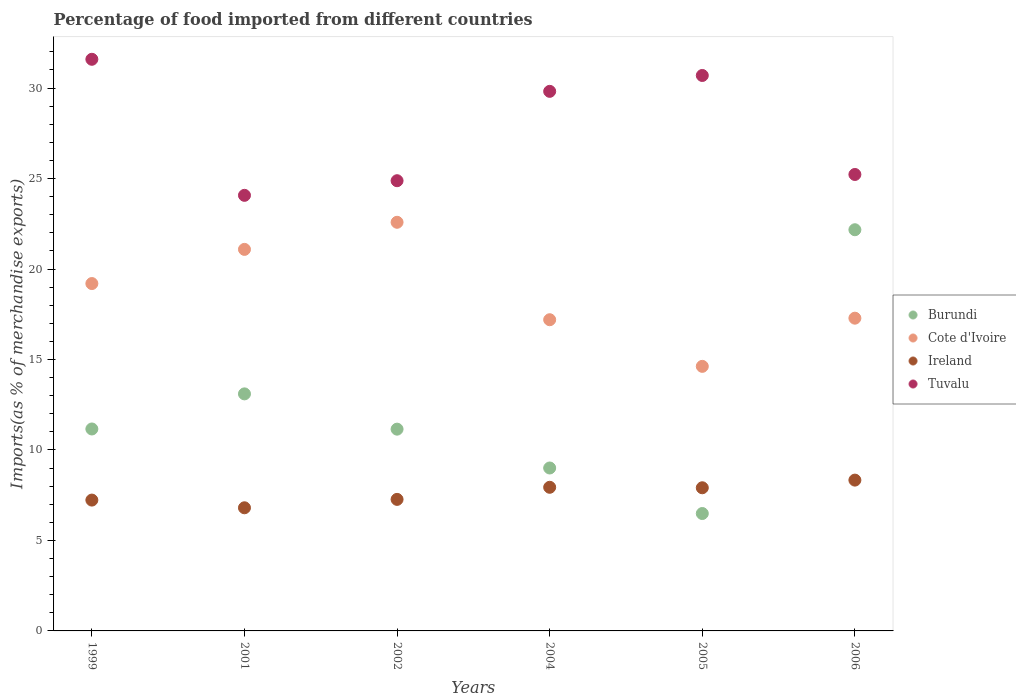What is the percentage of imports to different countries in Ireland in 1999?
Offer a terse response. 7.23. Across all years, what is the maximum percentage of imports to different countries in Tuvalu?
Provide a succinct answer. 31.59. Across all years, what is the minimum percentage of imports to different countries in Burundi?
Your answer should be very brief. 6.49. In which year was the percentage of imports to different countries in Cote d'Ivoire maximum?
Offer a very short reply. 2002. In which year was the percentage of imports to different countries in Cote d'Ivoire minimum?
Keep it short and to the point. 2005. What is the total percentage of imports to different countries in Ireland in the graph?
Your answer should be compact. 45.49. What is the difference between the percentage of imports to different countries in Cote d'Ivoire in 2001 and that in 2006?
Make the answer very short. 3.8. What is the difference between the percentage of imports to different countries in Cote d'Ivoire in 1999 and the percentage of imports to different countries in Ireland in 2005?
Provide a succinct answer. 11.29. What is the average percentage of imports to different countries in Cote d'Ivoire per year?
Keep it short and to the point. 18.66. In the year 2005, what is the difference between the percentage of imports to different countries in Tuvalu and percentage of imports to different countries in Burundi?
Give a very brief answer. 24.21. What is the ratio of the percentage of imports to different countries in Tuvalu in 2004 to that in 2006?
Provide a short and direct response. 1.18. Is the percentage of imports to different countries in Ireland in 2005 less than that in 2006?
Make the answer very short. Yes. Is the difference between the percentage of imports to different countries in Tuvalu in 2004 and 2005 greater than the difference between the percentage of imports to different countries in Burundi in 2004 and 2005?
Your response must be concise. No. What is the difference between the highest and the second highest percentage of imports to different countries in Cote d'Ivoire?
Offer a terse response. 1.5. What is the difference between the highest and the lowest percentage of imports to different countries in Burundi?
Provide a succinct answer. 15.68. Is it the case that in every year, the sum of the percentage of imports to different countries in Burundi and percentage of imports to different countries in Cote d'Ivoire  is greater than the sum of percentage of imports to different countries in Ireland and percentage of imports to different countries in Tuvalu?
Provide a succinct answer. Yes. Is the percentage of imports to different countries in Cote d'Ivoire strictly less than the percentage of imports to different countries in Tuvalu over the years?
Provide a short and direct response. Yes. What is the difference between two consecutive major ticks on the Y-axis?
Your answer should be very brief. 5. How are the legend labels stacked?
Provide a succinct answer. Vertical. What is the title of the graph?
Your response must be concise. Percentage of food imported from different countries. Does "Iceland" appear as one of the legend labels in the graph?
Offer a terse response. No. What is the label or title of the X-axis?
Give a very brief answer. Years. What is the label or title of the Y-axis?
Ensure brevity in your answer.  Imports(as % of merchandise exports). What is the Imports(as % of merchandise exports) in Burundi in 1999?
Provide a short and direct response. 11.16. What is the Imports(as % of merchandise exports) in Cote d'Ivoire in 1999?
Provide a short and direct response. 19.2. What is the Imports(as % of merchandise exports) in Ireland in 1999?
Offer a terse response. 7.23. What is the Imports(as % of merchandise exports) of Tuvalu in 1999?
Your response must be concise. 31.59. What is the Imports(as % of merchandise exports) of Burundi in 2001?
Keep it short and to the point. 13.1. What is the Imports(as % of merchandise exports) in Cote d'Ivoire in 2001?
Ensure brevity in your answer.  21.09. What is the Imports(as % of merchandise exports) in Ireland in 2001?
Your answer should be compact. 6.8. What is the Imports(as % of merchandise exports) in Tuvalu in 2001?
Make the answer very short. 24.07. What is the Imports(as % of merchandise exports) of Burundi in 2002?
Offer a very short reply. 11.15. What is the Imports(as % of merchandise exports) in Cote d'Ivoire in 2002?
Your answer should be very brief. 22.58. What is the Imports(as % of merchandise exports) of Ireland in 2002?
Your answer should be compact. 7.27. What is the Imports(as % of merchandise exports) of Tuvalu in 2002?
Provide a succinct answer. 24.88. What is the Imports(as % of merchandise exports) of Burundi in 2004?
Provide a short and direct response. 9. What is the Imports(as % of merchandise exports) in Cote d'Ivoire in 2004?
Make the answer very short. 17.2. What is the Imports(as % of merchandise exports) in Ireland in 2004?
Offer a very short reply. 7.94. What is the Imports(as % of merchandise exports) in Tuvalu in 2004?
Keep it short and to the point. 29.82. What is the Imports(as % of merchandise exports) of Burundi in 2005?
Ensure brevity in your answer.  6.49. What is the Imports(as % of merchandise exports) in Cote d'Ivoire in 2005?
Provide a short and direct response. 14.62. What is the Imports(as % of merchandise exports) of Ireland in 2005?
Offer a very short reply. 7.91. What is the Imports(as % of merchandise exports) in Tuvalu in 2005?
Provide a short and direct response. 30.7. What is the Imports(as % of merchandise exports) of Burundi in 2006?
Ensure brevity in your answer.  22.17. What is the Imports(as % of merchandise exports) of Cote d'Ivoire in 2006?
Your response must be concise. 17.28. What is the Imports(as % of merchandise exports) of Ireland in 2006?
Provide a succinct answer. 8.33. What is the Imports(as % of merchandise exports) in Tuvalu in 2006?
Offer a very short reply. 25.22. Across all years, what is the maximum Imports(as % of merchandise exports) of Burundi?
Offer a very short reply. 22.17. Across all years, what is the maximum Imports(as % of merchandise exports) of Cote d'Ivoire?
Give a very brief answer. 22.58. Across all years, what is the maximum Imports(as % of merchandise exports) of Ireland?
Provide a short and direct response. 8.33. Across all years, what is the maximum Imports(as % of merchandise exports) of Tuvalu?
Offer a terse response. 31.59. Across all years, what is the minimum Imports(as % of merchandise exports) in Burundi?
Make the answer very short. 6.49. Across all years, what is the minimum Imports(as % of merchandise exports) in Cote d'Ivoire?
Make the answer very short. 14.62. Across all years, what is the minimum Imports(as % of merchandise exports) of Ireland?
Your answer should be very brief. 6.8. Across all years, what is the minimum Imports(as % of merchandise exports) in Tuvalu?
Provide a succinct answer. 24.07. What is the total Imports(as % of merchandise exports) in Burundi in the graph?
Give a very brief answer. 73.07. What is the total Imports(as % of merchandise exports) in Cote d'Ivoire in the graph?
Provide a short and direct response. 111.97. What is the total Imports(as % of merchandise exports) of Ireland in the graph?
Provide a succinct answer. 45.49. What is the total Imports(as % of merchandise exports) of Tuvalu in the graph?
Keep it short and to the point. 166.28. What is the difference between the Imports(as % of merchandise exports) in Burundi in 1999 and that in 2001?
Your response must be concise. -1.94. What is the difference between the Imports(as % of merchandise exports) of Cote d'Ivoire in 1999 and that in 2001?
Provide a short and direct response. -1.89. What is the difference between the Imports(as % of merchandise exports) of Ireland in 1999 and that in 2001?
Provide a short and direct response. 0.43. What is the difference between the Imports(as % of merchandise exports) of Tuvalu in 1999 and that in 2001?
Your answer should be compact. 7.52. What is the difference between the Imports(as % of merchandise exports) of Burundi in 1999 and that in 2002?
Give a very brief answer. 0.01. What is the difference between the Imports(as % of merchandise exports) of Cote d'Ivoire in 1999 and that in 2002?
Your answer should be compact. -3.39. What is the difference between the Imports(as % of merchandise exports) in Ireland in 1999 and that in 2002?
Your response must be concise. -0.04. What is the difference between the Imports(as % of merchandise exports) of Tuvalu in 1999 and that in 2002?
Your answer should be very brief. 6.71. What is the difference between the Imports(as % of merchandise exports) of Burundi in 1999 and that in 2004?
Ensure brevity in your answer.  2.16. What is the difference between the Imports(as % of merchandise exports) in Cote d'Ivoire in 1999 and that in 2004?
Provide a short and direct response. 2. What is the difference between the Imports(as % of merchandise exports) in Ireland in 1999 and that in 2004?
Ensure brevity in your answer.  -0.71. What is the difference between the Imports(as % of merchandise exports) in Tuvalu in 1999 and that in 2004?
Offer a very short reply. 1.77. What is the difference between the Imports(as % of merchandise exports) of Burundi in 1999 and that in 2005?
Keep it short and to the point. 4.67. What is the difference between the Imports(as % of merchandise exports) of Cote d'Ivoire in 1999 and that in 2005?
Your response must be concise. 4.58. What is the difference between the Imports(as % of merchandise exports) of Ireland in 1999 and that in 2005?
Your answer should be compact. -0.68. What is the difference between the Imports(as % of merchandise exports) of Tuvalu in 1999 and that in 2005?
Keep it short and to the point. 0.89. What is the difference between the Imports(as % of merchandise exports) in Burundi in 1999 and that in 2006?
Provide a short and direct response. -11.01. What is the difference between the Imports(as % of merchandise exports) in Cote d'Ivoire in 1999 and that in 2006?
Your response must be concise. 1.91. What is the difference between the Imports(as % of merchandise exports) of Ireland in 1999 and that in 2006?
Ensure brevity in your answer.  -1.1. What is the difference between the Imports(as % of merchandise exports) of Tuvalu in 1999 and that in 2006?
Ensure brevity in your answer.  6.37. What is the difference between the Imports(as % of merchandise exports) of Burundi in 2001 and that in 2002?
Offer a terse response. 1.95. What is the difference between the Imports(as % of merchandise exports) in Cote d'Ivoire in 2001 and that in 2002?
Your answer should be compact. -1.5. What is the difference between the Imports(as % of merchandise exports) in Ireland in 2001 and that in 2002?
Keep it short and to the point. -0.46. What is the difference between the Imports(as % of merchandise exports) of Tuvalu in 2001 and that in 2002?
Your response must be concise. -0.81. What is the difference between the Imports(as % of merchandise exports) in Burundi in 2001 and that in 2004?
Your answer should be very brief. 4.1. What is the difference between the Imports(as % of merchandise exports) of Cote d'Ivoire in 2001 and that in 2004?
Your response must be concise. 3.89. What is the difference between the Imports(as % of merchandise exports) in Ireland in 2001 and that in 2004?
Keep it short and to the point. -1.13. What is the difference between the Imports(as % of merchandise exports) of Tuvalu in 2001 and that in 2004?
Provide a short and direct response. -5.75. What is the difference between the Imports(as % of merchandise exports) of Burundi in 2001 and that in 2005?
Give a very brief answer. 6.61. What is the difference between the Imports(as % of merchandise exports) in Cote d'Ivoire in 2001 and that in 2005?
Offer a very short reply. 6.46. What is the difference between the Imports(as % of merchandise exports) of Ireland in 2001 and that in 2005?
Offer a very short reply. -1.11. What is the difference between the Imports(as % of merchandise exports) of Tuvalu in 2001 and that in 2005?
Give a very brief answer. -6.62. What is the difference between the Imports(as % of merchandise exports) of Burundi in 2001 and that in 2006?
Offer a terse response. -9.07. What is the difference between the Imports(as % of merchandise exports) in Cote d'Ivoire in 2001 and that in 2006?
Provide a short and direct response. 3.8. What is the difference between the Imports(as % of merchandise exports) of Ireland in 2001 and that in 2006?
Provide a short and direct response. -1.53. What is the difference between the Imports(as % of merchandise exports) of Tuvalu in 2001 and that in 2006?
Keep it short and to the point. -1.15. What is the difference between the Imports(as % of merchandise exports) in Burundi in 2002 and that in 2004?
Your answer should be very brief. 2.15. What is the difference between the Imports(as % of merchandise exports) of Cote d'Ivoire in 2002 and that in 2004?
Provide a short and direct response. 5.38. What is the difference between the Imports(as % of merchandise exports) in Ireland in 2002 and that in 2004?
Provide a short and direct response. -0.67. What is the difference between the Imports(as % of merchandise exports) of Tuvalu in 2002 and that in 2004?
Make the answer very short. -4.94. What is the difference between the Imports(as % of merchandise exports) in Burundi in 2002 and that in 2005?
Offer a terse response. 4.66. What is the difference between the Imports(as % of merchandise exports) of Cote d'Ivoire in 2002 and that in 2005?
Keep it short and to the point. 7.96. What is the difference between the Imports(as % of merchandise exports) of Ireland in 2002 and that in 2005?
Give a very brief answer. -0.64. What is the difference between the Imports(as % of merchandise exports) in Tuvalu in 2002 and that in 2005?
Provide a succinct answer. -5.82. What is the difference between the Imports(as % of merchandise exports) in Burundi in 2002 and that in 2006?
Offer a terse response. -11.02. What is the difference between the Imports(as % of merchandise exports) in Cote d'Ivoire in 2002 and that in 2006?
Make the answer very short. 5.3. What is the difference between the Imports(as % of merchandise exports) of Ireland in 2002 and that in 2006?
Provide a short and direct response. -1.07. What is the difference between the Imports(as % of merchandise exports) in Tuvalu in 2002 and that in 2006?
Provide a short and direct response. -0.34. What is the difference between the Imports(as % of merchandise exports) of Burundi in 2004 and that in 2005?
Ensure brevity in your answer.  2.52. What is the difference between the Imports(as % of merchandise exports) of Cote d'Ivoire in 2004 and that in 2005?
Provide a short and direct response. 2.58. What is the difference between the Imports(as % of merchandise exports) of Ireland in 2004 and that in 2005?
Give a very brief answer. 0.03. What is the difference between the Imports(as % of merchandise exports) in Tuvalu in 2004 and that in 2005?
Provide a short and direct response. -0.88. What is the difference between the Imports(as % of merchandise exports) of Burundi in 2004 and that in 2006?
Give a very brief answer. -13.17. What is the difference between the Imports(as % of merchandise exports) of Cote d'Ivoire in 2004 and that in 2006?
Keep it short and to the point. -0.09. What is the difference between the Imports(as % of merchandise exports) in Ireland in 2004 and that in 2006?
Offer a very short reply. -0.4. What is the difference between the Imports(as % of merchandise exports) in Tuvalu in 2004 and that in 2006?
Provide a succinct answer. 4.59. What is the difference between the Imports(as % of merchandise exports) in Burundi in 2005 and that in 2006?
Make the answer very short. -15.68. What is the difference between the Imports(as % of merchandise exports) in Cote d'Ivoire in 2005 and that in 2006?
Give a very brief answer. -2.66. What is the difference between the Imports(as % of merchandise exports) of Ireland in 2005 and that in 2006?
Provide a succinct answer. -0.42. What is the difference between the Imports(as % of merchandise exports) in Tuvalu in 2005 and that in 2006?
Provide a short and direct response. 5.47. What is the difference between the Imports(as % of merchandise exports) in Burundi in 1999 and the Imports(as % of merchandise exports) in Cote d'Ivoire in 2001?
Offer a terse response. -9.93. What is the difference between the Imports(as % of merchandise exports) of Burundi in 1999 and the Imports(as % of merchandise exports) of Ireland in 2001?
Your answer should be very brief. 4.36. What is the difference between the Imports(as % of merchandise exports) of Burundi in 1999 and the Imports(as % of merchandise exports) of Tuvalu in 2001?
Ensure brevity in your answer.  -12.91. What is the difference between the Imports(as % of merchandise exports) of Cote d'Ivoire in 1999 and the Imports(as % of merchandise exports) of Ireland in 2001?
Keep it short and to the point. 12.39. What is the difference between the Imports(as % of merchandise exports) in Cote d'Ivoire in 1999 and the Imports(as % of merchandise exports) in Tuvalu in 2001?
Ensure brevity in your answer.  -4.88. What is the difference between the Imports(as % of merchandise exports) of Ireland in 1999 and the Imports(as % of merchandise exports) of Tuvalu in 2001?
Ensure brevity in your answer.  -16.84. What is the difference between the Imports(as % of merchandise exports) of Burundi in 1999 and the Imports(as % of merchandise exports) of Cote d'Ivoire in 2002?
Keep it short and to the point. -11.42. What is the difference between the Imports(as % of merchandise exports) of Burundi in 1999 and the Imports(as % of merchandise exports) of Ireland in 2002?
Keep it short and to the point. 3.89. What is the difference between the Imports(as % of merchandise exports) in Burundi in 1999 and the Imports(as % of merchandise exports) in Tuvalu in 2002?
Offer a terse response. -13.72. What is the difference between the Imports(as % of merchandise exports) in Cote d'Ivoire in 1999 and the Imports(as % of merchandise exports) in Ireland in 2002?
Your response must be concise. 11.93. What is the difference between the Imports(as % of merchandise exports) in Cote d'Ivoire in 1999 and the Imports(as % of merchandise exports) in Tuvalu in 2002?
Offer a terse response. -5.68. What is the difference between the Imports(as % of merchandise exports) in Ireland in 1999 and the Imports(as % of merchandise exports) in Tuvalu in 2002?
Your answer should be compact. -17.65. What is the difference between the Imports(as % of merchandise exports) in Burundi in 1999 and the Imports(as % of merchandise exports) in Cote d'Ivoire in 2004?
Your answer should be very brief. -6.04. What is the difference between the Imports(as % of merchandise exports) of Burundi in 1999 and the Imports(as % of merchandise exports) of Ireland in 2004?
Ensure brevity in your answer.  3.22. What is the difference between the Imports(as % of merchandise exports) of Burundi in 1999 and the Imports(as % of merchandise exports) of Tuvalu in 2004?
Offer a very short reply. -18.66. What is the difference between the Imports(as % of merchandise exports) in Cote d'Ivoire in 1999 and the Imports(as % of merchandise exports) in Ireland in 2004?
Your answer should be compact. 11.26. What is the difference between the Imports(as % of merchandise exports) in Cote d'Ivoire in 1999 and the Imports(as % of merchandise exports) in Tuvalu in 2004?
Offer a terse response. -10.62. What is the difference between the Imports(as % of merchandise exports) of Ireland in 1999 and the Imports(as % of merchandise exports) of Tuvalu in 2004?
Ensure brevity in your answer.  -22.59. What is the difference between the Imports(as % of merchandise exports) of Burundi in 1999 and the Imports(as % of merchandise exports) of Cote d'Ivoire in 2005?
Provide a short and direct response. -3.46. What is the difference between the Imports(as % of merchandise exports) of Burundi in 1999 and the Imports(as % of merchandise exports) of Ireland in 2005?
Provide a succinct answer. 3.25. What is the difference between the Imports(as % of merchandise exports) in Burundi in 1999 and the Imports(as % of merchandise exports) in Tuvalu in 2005?
Offer a terse response. -19.54. What is the difference between the Imports(as % of merchandise exports) in Cote d'Ivoire in 1999 and the Imports(as % of merchandise exports) in Ireland in 2005?
Provide a succinct answer. 11.29. What is the difference between the Imports(as % of merchandise exports) in Cote d'Ivoire in 1999 and the Imports(as % of merchandise exports) in Tuvalu in 2005?
Your answer should be compact. -11.5. What is the difference between the Imports(as % of merchandise exports) in Ireland in 1999 and the Imports(as % of merchandise exports) in Tuvalu in 2005?
Give a very brief answer. -23.46. What is the difference between the Imports(as % of merchandise exports) of Burundi in 1999 and the Imports(as % of merchandise exports) of Cote d'Ivoire in 2006?
Provide a short and direct response. -6.12. What is the difference between the Imports(as % of merchandise exports) in Burundi in 1999 and the Imports(as % of merchandise exports) in Ireland in 2006?
Your answer should be very brief. 2.83. What is the difference between the Imports(as % of merchandise exports) of Burundi in 1999 and the Imports(as % of merchandise exports) of Tuvalu in 2006?
Make the answer very short. -14.06. What is the difference between the Imports(as % of merchandise exports) in Cote d'Ivoire in 1999 and the Imports(as % of merchandise exports) in Ireland in 2006?
Give a very brief answer. 10.86. What is the difference between the Imports(as % of merchandise exports) in Cote d'Ivoire in 1999 and the Imports(as % of merchandise exports) in Tuvalu in 2006?
Provide a succinct answer. -6.03. What is the difference between the Imports(as % of merchandise exports) in Ireland in 1999 and the Imports(as % of merchandise exports) in Tuvalu in 2006?
Your answer should be compact. -17.99. What is the difference between the Imports(as % of merchandise exports) of Burundi in 2001 and the Imports(as % of merchandise exports) of Cote d'Ivoire in 2002?
Ensure brevity in your answer.  -9.48. What is the difference between the Imports(as % of merchandise exports) of Burundi in 2001 and the Imports(as % of merchandise exports) of Ireland in 2002?
Offer a terse response. 5.83. What is the difference between the Imports(as % of merchandise exports) in Burundi in 2001 and the Imports(as % of merchandise exports) in Tuvalu in 2002?
Ensure brevity in your answer.  -11.78. What is the difference between the Imports(as % of merchandise exports) of Cote d'Ivoire in 2001 and the Imports(as % of merchandise exports) of Ireland in 2002?
Give a very brief answer. 13.82. What is the difference between the Imports(as % of merchandise exports) of Cote d'Ivoire in 2001 and the Imports(as % of merchandise exports) of Tuvalu in 2002?
Ensure brevity in your answer.  -3.79. What is the difference between the Imports(as % of merchandise exports) in Ireland in 2001 and the Imports(as % of merchandise exports) in Tuvalu in 2002?
Provide a succinct answer. -18.07. What is the difference between the Imports(as % of merchandise exports) of Burundi in 2001 and the Imports(as % of merchandise exports) of Cote d'Ivoire in 2004?
Offer a terse response. -4.1. What is the difference between the Imports(as % of merchandise exports) in Burundi in 2001 and the Imports(as % of merchandise exports) in Ireland in 2004?
Provide a short and direct response. 5.16. What is the difference between the Imports(as % of merchandise exports) of Burundi in 2001 and the Imports(as % of merchandise exports) of Tuvalu in 2004?
Provide a short and direct response. -16.72. What is the difference between the Imports(as % of merchandise exports) of Cote d'Ivoire in 2001 and the Imports(as % of merchandise exports) of Ireland in 2004?
Offer a very short reply. 13.15. What is the difference between the Imports(as % of merchandise exports) of Cote d'Ivoire in 2001 and the Imports(as % of merchandise exports) of Tuvalu in 2004?
Keep it short and to the point. -8.73. What is the difference between the Imports(as % of merchandise exports) in Ireland in 2001 and the Imports(as % of merchandise exports) in Tuvalu in 2004?
Make the answer very short. -23.01. What is the difference between the Imports(as % of merchandise exports) in Burundi in 2001 and the Imports(as % of merchandise exports) in Cote d'Ivoire in 2005?
Offer a very short reply. -1.52. What is the difference between the Imports(as % of merchandise exports) in Burundi in 2001 and the Imports(as % of merchandise exports) in Ireland in 2005?
Provide a succinct answer. 5.19. What is the difference between the Imports(as % of merchandise exports) of Burundi in 2001 and the Imports(as % of merchandise exports) of Tuvalu in 2005?
Provide a succinct answer. -17.6. What is the difference between the Imports(as % of merchandise exports) in Cote d'Ivoire in 2001 and the Imports(as % of merchandise exports) in Ireland in 2005?
Give a very brief answer. 13.17. What is the difference between the Imports(as % of merchandise exports) in Cote d'Ivoire in 2001 and the Imports(as % of merchandise exports) in Tuvalu in 2005?
Ensure brevity in your answer.  -9.61. What is the difference between the Imports(as % of merchandise exports) in Ireland in 2001 and the Imports(as % of merchandise exports) in Tuvalu in 2005?
Give a very brief answer. -23.89. What is the difference between the Imports(as % of merchandise exports) of Burundi in 2001 and the Imports(as % of merchandise exports) of Cote d'Ivoire in 2006?
Provide a short and direct response. -4.18. What is the difference between the Imports(as % of merchandise exports) of Burundi in 2001 and the Imports(as % of merchandise exports) of Ireland in 2006?
Provide a succinct answer. 4.77. What is the difference between the Imports(as % of merchandise exports) of Burundi in 2001 and the Imports(as % of merchandise exports) of Tuvalu in 2006?
Provide a succinct answer. -12.12. What is the difference between the Imports(as % of merchandise exports) in Cote d'Ivoire in 2001 and the Imports(as % of merchandise exports) in Ireland in 2006?
Your response must be concise. 12.75. What is the difference between the Imports(as % of merchandise exports) in Cote d'Ivoire in 2001 and the Imports(as % of merchandise exports) in Tuvalu in 2006?
Provide a short and direct response. -4.14. What is the difference between the Imports(as % of merchandise exports) in Ireland in 2001 and the Imports(as % of merchandise exports) in Tuvalu in 2006?
Provide a short and direct response. -18.42. What is the difference between the Imports(as % of merchandise exports) of Burundi in 2002 and the Imports(as % of merchandise exports) of Cote d'Ivoire in 2004?
Keep it short and to the point. -6.05. What is the difference between the Imports(as % of merchandise exports) in Burundi in 2002 and the Imports(as % of merchandise exports) in Ireland in 2004?
Ensure brevity in your answer.  3.21. What is the difference between the Imports(as % of merchandise exports) in Burundi in 2002 and the Imports(as % of merchandise exports) in Tuvalu in 2004?
Give a very brief answer. -18.67. What is the difference between the Imports(as % of merchandise exports) in Cote d'Ivoire in 2002 and the Imports(as % of merchandise exports) in Ireland in 2004?
Provide a succinct answer. 14.65. What is the difference between the Imports(as % of merchandise exports) in Cote d'Ivoire in 2002 and the Imports(as % of merchandise exports) in Tuvalu in 2004?
Provide a succinct answer. -7.24. What is the difference between the Imports(as % of merchandise exports) in Ireland in 2002 and the Imports(as % of merchandise exports) in Tuvalu in 2004?
Provide a succinct answer. -22.55. What is the difference between the Imports(as % of merchandise exports) in Burundi in 2002 and the Imports(as % of merchandise exports) in Cote d'Ivoire in 2005?
Offer a very short reply. -3.47. What is the difference between the Imports(as % of merchandise exports) of Burundi in 2002 and the Imports(as % of merchandise exports) of Ireland in 2005?
Offer a terse response. 3.24. What is the difference between the Imports(as % of merchandise exports) in Burundi in 2002 and the Imports(as % of merchandise exports) in Tuvalu in 2005?
Provide a succinct answer. -19.55. What is the difference between the Imports(as % of merchandise exports) of Cote d'Ivoire in 2002 and the Imports(as % of merchandise exports) of Ireland in 2005?
Your answer should be compact. 14.67. What is the difference between the Imports(as % of merchandise exports) in Cote d'Ivoire in 2002 and the Imports(as % of merchandise exports) in Tuvalu in 2005?
Offer a terse response. -8.11. What is the difference between the Imports(as % of merchandise exports) of Ireland in 2002 and the Imports(as % of merchandise exports) of Tuvalu in 2005?
Your answer should be very brief. -23.43. What is the difference between the Imports(as % of merchandise exports) in Burundi in 2002 and the Imports(as % of merchandise exports) in Cote d'Ivoire in 2006?
Your answer should be compact. -6.13. What is the difference between the Imports(as % of merchandise exports) in Burundi in 2002 and the Imports(as % of merchandise exports) in Ireland in 2006?
Your answer should be compact. 2.82. What is the difference between the Imports(as % of merchandise exports) of Burundi in 2002 and the Imports(as % of merchandise exports) of Tuvalu in 2006?
Ensure brevity in your answer.  -14.07. What is the difference between the Imports(as % of merchandise exports) of Cote d'Ivoire in 2002 and the Imports(as % of merchandise exports) of Ireland in 2006?
Your answer should be compact. 14.25. What is the difference between the Imports(as % of merchandise exports) of Cote d'Ivoire in 2002 and the Imports(as % of merchandise exports) of Tuvalu in 2006?
Provide a succinct answer. -2.64. What is the difference between the Imports(as % of merchandise exports) in Ireland in 2002 and the Imports(as % of merchandise exports) in Tuvalu in 2006?
Give a very brief answer. -17.96. What is the difference between the Imports(as % of merchandise exports) in Burundi in 2004 and the Imports(as % of merchandise exports) in Cote d'Ivoire in 2005?
Your response must be concise. -5.62. What is the difference between the Imports(as % of merchandise exports) of Burundi in 2004 and the Imports(as % of merchandise exports) of Ireland in 2005?
Offer a very short reply. 1.09. What is the difference between the Imports(as % of merchandise exports) of Burundi in 2004 and the Imports(as % of merchandise exports) of Tuvalu in 2005?
Your answer should be compact. -21.69. What is the difference between the Imports(as % of merchandise exports) in Cote d'Ivoire in 2004 and the Imports(as % of merchandise exports) in Ireland in 2005?
Your answer should be very brief. 9.29. What is the difference between the Imports(as % of merchandise exports) in Cote d'Ivoire in 2004 and the Imports(as % of merchandise exports) in Tuvalu in 2005?
Your answer should be very brief. -13.5. What is the difference between the Imports(as % of merchandise exports) of Ireland in 2004 and the Imports(as % of merchandise exports) of Tuvalu in 2005?
Provide a short and direct response. -22.76. What is the difference between the Imports(as % of merchandise exports) of Burundi in 2004 and the Imports(as % of merchandise exports) of Cote d'Ivoire in 2006?
Keep it short and to the point. -8.28. What is the difference between the Imports(as % of merchandise exports) in Burundi in 2004 and the Imports(as % of merchandise exports) in Ireland in 2006?
Provide a short and direct response. 0.67. What is the difference between the Imports(as % of merchandise exports) of Burundi in 2004 and the Imports(as % of merchandise exports) of Tuvalu in 2006?
Your response must be concise. -16.22. What is the difference between the Imports(as % of merchandise exports) of Cote d'Ivoire in 2004 and the Imports(as % of merchandise exports) of Ireland in 2006?
Your answer should be very brief. 8.86. What is the difference between the Imports(as % of merchandise exports) in Cote d'Ivoire in 2004 and the Imports(as % of merchandise exports) in Tuvalu in 2006?
Give a very brief answer. -8.03. What is the difference between the Imports(as % of merchandise exports) in Ireland in 2004 and the Imports(as % of merchandise exports) in Tuvalu in 2006?
Give a very brief answer. -17.29. What is the difference between the Imports(as % of merchandise exports) in Burundi in 2005 and the Imports(as % of merchandise exports) in Cote d'Ivoire in 2006?
Make the answer very short. -10.8. What is the difference between the Imports(as % of merchandise exports) in Burundi in 2005 and the Imports(as % of merchandise exports) in Ireland in 2006?
Give a very brief answer. -1.85. What is the difference between the Imports(as % of merchandise exports) of Burundi in 2005 and the Imports(as % of merchandise exports) of Tuvalu in 2006?
Your response must be concise. -18.74. What is the difference between the Imports(as % of merchandise exports) of Cote d'Ivoire in 2005 and the Imports(as % of merchandise exports) of Ireland in 2006?
Give a very brief answer. 6.29. What is the difference between the Imports(as % of merchandise exports) in Cote d'Ivoire in 2005 and the Imports(as % of merchandise exports) in Tuvalu in 2006?
Your answer should be compact. -10.6. What is the difference between the Imports(as % of merchandise exports) in Ireland in 2005 and the Imports(as % of merchandise exports) in Tuvalu in 2006?
Give a very brief answer. -17.31. What is the average Imports(as % of merchandise exports) of Burundi per year?
Your answer should be very brief. 12.18. What is the average Imports(as % of merchandise exports) of Cote d'Ivoire per year?
Your response must be concise. 18.66. What is the average Imports(as % of merchandise exports) of Ireland per year?
Provide a succinct answer. 7.58. What is the average Imports(as % of merchandise exports) of Tuvalu per year?
Your answer should be very brief. 27.71. In the year 1999, what is the difference between the Imports(as % of merchandise exports) in Burundi and Imports(as % of merchandise exports) in Cote d'Ivoire?
Keep it short and to the point. -8.04. In the year 1999, what is the difference between the Imports(as % of merchandise exports) of Burundi and Imports(as % of merchandise exports) of Ireland?
Provide a short and direct response. 3.93. In the year 1999, what is the difference between the Imports(as % of merchandise exports) in Burundi and Imports(as % of merchandise exports) in Tuvalu?
Provide a succinct answer. -20.43. In the year 1999, what is the difference between the Imports(as % of merchandise exports) in Cote d'Ivoire and Imports(as % of merchandise exports) in Ireland?
Offer a very short reply. 11.97. In the year 1999, what is the difference between the Imports(as % of merchandise exports) in Cote d'Ivoire and Imports(as % of merchandise exports) in Tuvalu?
Make the answer very short. -12.39. In the year 1999, what is the difference between the Imports(as % of merchandise exports) in Ireland and Imports(as % of merchandise exports) in Tuvalu?
Give a very brief answer. -24.36. In the year 2001, what is the difference between the Imports(as % of merchandise exports) of Burundi and Imports(as % of merchandise exports) of Cote d'Ivoire?
Your answer should be very brief. -7.99. In the year 2001, what is the difference between the Imports(as % of merchandise exports) in Burundi and Imports(as % of merchandise exports) in Ireland?
Make the answer very short. 6.29. In the year 2001, what is the difference between the Imports(as % of merchandise exports) of Burundi and Imports(as % of merchandise exports) of Tuvalu?
Your response must be concise. -10.97. In the year 2001, what is the difference between the Imports(as % of merchandise exports) in Cote d'Ivoire and Imports(as % of merchandise exports) in Ireland?
Ensure brevity in your answer.  14.28. In the year 2001, what is the difference between the Imports(as % of merchandise exports) of Cote d'Ivoire and Imports(as % of merchandise exports) of Tuvalu?
Provide a short and direct response. -2.99. In the year 2001, what is the difference between the Imports(as % of merchandise exports) in Ireland and Imports(as % of merchandise exports) in Tuvalu?
Provide a succinct answer. -17.27. In the year 2002, what is the difference between the Imports(as % of merchandise exports) of Burundi and Imports(as % of merchandise exports) of Cote d'Ivoire?
Offer a terse response. -11.43. In the year 2002, what is the difference between the Imports(as % of merchandise exports) in Burundi and Imports(as % of merchandise exports) in Ireland?
Offer a terse response. 3.88. In the year 2002, what is the difference between the Imports(as % of merchandise exports) of Burundi and Imports(as % of merchandise exports) of Tuvalu?
Make the answer very short. -13.73. In the year 2002, what is the difference between the Imports(as % of merchandise exports) of Cote d'Ivoire and Imports(as % of merchandise exports) of Ireland?
Your response must be concise. 15.31. In the year 2002, what is the difference between the Imports(as % of merchandise exports) in Cote d'Ivoire and Imports(as % of merchandise exports) in Tuvalu?
Ensure brevity in your answer.  -2.3. In the year 2002, what is the difference between the Imports(as % of merchandise exports) of Ireland and Imports(as % of merchandise exports) of Tuvalu?
Your answer should be compact. -17.61. In the year 2004, what is the difference between the Imports(as % of merchandise exports) of Burundi and Imports(as % of merchandise exports) of Cote d'Ivoire?
Make the answer very short. -8.19. In the year 2004, what is the difference between the Imports(as % of merchandise exports) of Burundi and Imports(as % of merchandise exports) of Ireland?
Keep it short and to the point. 1.07. In the year 2004, what is the difference between the Imports(as % of merchandise exports) in Burundi and Imports(as % of merchandise exports) in Tuvalu?
Your answer should be compact. -20.81. In the year 2004, what is the difference between the Imports(as % of merchandise exports) of Cote d'Ivoire and Imports(as % of merchandise exports) of Ireland?
Your response must be concise. 9.26. In the year 2004, what is the difference between the Imports(as % of merchandise exports) of Cote d'Ivoire and Imports(as % of merchandise exports) of Tuvalu?
Make the answer very short. -12.62. In the year 2004, what is the difference between the Imports(as % of merchandise exports) in Ireland and Imports(as % of merchandise exports) in Tuvalu?
Ensure brevity in your answer.  -21.88. In the year 2005, what is the difference between the Imports(as % of merchandise exports) in Burundi and Imports(as % of merchandise exports) in Cote d'Ivoire?
Your answer should be compact. -8.13. In the year 2005, what is the difference between the Imports(as % of merchandise exports) of Burundi and Imports(as % of merchandise exports) of Ireland?
Keep it short and to the point. -1.42. In the year 2005, what is the difference between the Imports(as % of merchandise exports) in Burundi and Imports(as % of merchandise exports) in Tuvalu?
Offer a very short reply. -24.21. In the year 2005, what is the difference between the Imports(as % of merchandise exports) of Cote d'Ivoire and Imports(as % of merchandise exports) of Ireland?
Offer a terse response. 6.71. In the year 2005, what is the difference between the Imports(as % of merchandise exports) of Cote d'Ivoire and Imports(as % of merchandise exports) of Tuvalu?
Your answer should be very brief. -16.07. In the year 2005, what is the difference between the Imports(as % of merchandise exports) of Ireland and Imports(as % of merchandise exports) of Tuvalu?
Provide a succinct answer. -22.78. In the year 2006, what is the difference between the Imports(as % of merchandise exports) in Burundi and Imports(as % of merchandise exports) in Cote d'Ivoire?
Your answer should be very brief. 4.89. In the year 2006, what is the difference between the Imports(as % of merchandise exports) of Burundi and Imports(as % of merchandise exports) of Ireland?
Provide a short and direct response. 13.84. In the year 2006, what is the difference between the Imports(as % of merchandise exports) of Burundi and Imports(as % of merchandise exports) of Tuvalu?
Offer a terse response. -3.05. In the year 2006, what is the difference between the Imports(as % of merchandise exports) of Cote d'Ivoire and Imports(as % of merchandise exports) of Ireland?
Your answer should be very brief. 8.95. In the year 2006, what is the difference between the Imports(as % of merchandise exports) in Cote d'Ivoire and Imports(as % of merchandise exports) in Tuvalu?
Make the answer very short. -7.94. In the year 2006, what is the difference between the Imports(as % of merchandise exports) of Ireland and Imports(as % of merchandise exports) of Tuvalu?
Ensure brevity in your answer.  -16.89. What is the ratio of the Imports(as % of merchandise exports) of Burundi in 1999 to that in 2001?
Your answer should be very brief. 0.85. What is the ratio of the Imports(as % of merchandise exports) of Cote d'Ivoire in 1999 to that in 2001?
Ensure brevity in your answer.  0.91. What is the ratio of the Imports(as % of merchandise exports) in Tuvalu in 1999 to that in 2001?
Your answer should be very brief. 1.31. What is the ratio of the Imports(as % of merchandise exports) of Burundi in 1999 to that in 2002?
Offer a terse response. 1. What is the ratio of the Imports(as % of merchandise exports) in Tuvalu in 1999 to that in 2002?
Your response must be concise. 1.27. What is the ratio of the Imports(as % of merchandise exports) in Burundi in 1999 to that in 2004?
Your answer should be compact. 1.24. What is the ratio of the Imports(as % of merchandise exports) in Cote d'Ivoire in 1999 to that in 2004?
Your response must be concise. 1.12. What is the ratio of the Imports(as % of merchandise exports) of Ireland in 1999 to that in 2004?
Make the answer very short. 0.91. What is the ratio of the Imports(as % of merchandise exports) in Tuvalu in 1999 to that in 2004?
Offer a terse response. 1.06. What is the ratio of the Imports(as % of merchandise exports) of Burundi in 1999 to that in 2005?
Ensure brevity in your answer.  1.72. What is the ratio of the Imports(as % of merchandise exports) in Cote d'Ivoire in 1999 to that in 2005?
Your answer should be compact. 1.31. What is the ratio of the Imports(as % of merchandise exports) of Ireland in 1999 to that in 2005?
Provide a short and direct response. 0.91. What is the ratio of the Imports(as % of merchandise exports) of Tuvalu in 1999 to that in 2005?
Provide a succinct answer. 1.03. What is the ratio of the Imports(as % of merchandise exports) of Burundi in 1999 to that in 2006?
Your answer should be compact. 0.5. What is the ratio of the Imports(as % of merchandise exports) of Cote d'Ivoire in 1999 to that in 2006?
Your answer should be compact. 1.11. What is the ratio of the Imports(as % of merchandise exports) of Ireland in 1999 to that in 2006?
Offer a terse response. 0.87. What is the ratio of the Imports(as % of merchandise exports) in Tuvalu in 1999 to that in 2006?
Offer a terse response. 1.25. What is the ratio of the Imports(as % of merchandise exports) of Burundi in 2001 to that in 2002?
Offer a very short reply. 1.17. What is the ratio of the Imports(as % of merchandise exports) in Cote d'Ivoire in 2001 to that in 2002?
Keep it short and to the point. 0.93. What is the ratio of the Imports(as % of merchandise exports) of Ireland in 2001 to that in 2002?
Give a very brief answer. 0.94. What is the ratio of the Imports(as % of merchandise exports) in Tuvalu in 2001 to that in 2002?
Your answer should be compact. 0.97. What is the ratio of the Imports(as % of merchandise exports) of Burundi in 2001 to that in 2004?
Provide a short and direct response. 1.45. What is the ratio of the Imports(as % of merchandise exports) of Cote d'Ivoire in 2001 to that in 2004?
Your answer should be very brief. 1.23. What is the ratio of the Imports(as % of merchandise exports) in Ireland in 2001 to that in 2004?
Your answer should be very brief. 0.86. What is the ratio of the Imports(as % of merchandise exports) of Tuvalu in 2001 to that in 2004?
Keep it short and to the point. 0.81. What is the ratio of the Imports(as % of merchandise exports) in Burundi in 2001 to that in 2005?
Make the answer very short. 2.02. What is the ratio of the Imports(as % of merchandise exports) in Cote d'Ivoire in 2001 to that in 2005?
Offer a terse response. 1.44. What is the ratio of the Imports(as % of merchandise exports) in Ireland in 2001 to that in 2005?
Provide a succinct answer. 0.86. What is the ratio of the Imports(as % of merchandise exports) in Tuvalu in 2001 to that in 2005?
Make the answer very short. 0.78. What is the ratio of the Imports(as % of merchandise exports) of Burundi in 2001 to that in 2006?
Your answer should be very brief. 0.59. What is the ratio of the Imports(as % of merchandise exports) in Cote d'Ivoire in 2001 to that in 2006?
Your answer should be compact. 1.22. What is the ratio of the Imports(as % of merchandise exports) of Ireland in 2001 to that in 2006?
Offer a terse response. 0.82. What is the ratio of the Imports(as % of merchandise exports) in Tuvalu in 2001 to that in 2006?
Give a very brief answer. 0.95. What is the ratio of the Imports(as % of merchandise exports) in Burundi in 2002 to that in 2004?
Your answer should be very brief. 1.24. What is the ratio of the Imports(as % of merchandise exports) of Cote d'Ivoire in 2002 to that in 2004?
Your answer should be very brief. 1.31. What is the ratio of the Imports(as % of merchandise exports) in Ireland in 2002 to that in 2004?
Provide a short and direct response. 0.92. What is the ratio of the Imports(as % of merchandise exports) in Tuvalu in 2002 to that in 2004?
Make the answer very short. 0.83. What is the ratio of the Imports(as % of merchandise exports) of Burundi in 2002 to that in 2005?
Offer a terse response. 1.72. What is the ratio of the Imports(as % of merchandise exports) of Cote d'Ivoire in 2002 to that in 2005?
Make the answer very short. 1.54. What is the ratio of the Imports(as % of merchandise exports) in Ireland in 2002 to that in 2005?
Offer a terse response. 0.92. What is the ratio of the Imports(as % of merchandise exports) of Tuvalu in 2002 to that in 2005?
Ensure brevity in your answer.  0.81. What is the ratio of the Imports(as % of merchandise exports) in Burundi in 2002 to that in 2006?
Provide a short and direct response. 0.5. What is the ratio of the Imports(as % of merchandise exports) of Cote d'Ivoire in 2002 to that in 2006?
Your answer should be very brief. 1.31. What is the ratio of the Imports(as % of merchandise exports) of Ireland in 2002 to that in 2006?
Make the answer very short. 0.87. What is the ratio of the Imports(as % of merchandise exports) in Tuvalu in 2002 to that in 2006?
Your answer should be very brief. 0.99. What is the ratio of the Imports(as % of merchandise exports) of Burundi in 2004 to that in 2005?
Make the answer very short. 1.39. What is the ratio of the Imports(as % of merchandise exports) in Cote d'Ivoire in 2004 to that in 2005?
Provide a short and direct response. 1.18. What is the ratio of the Imports(as % of merchandise exports) of Ireland in 2004 to that in 2005?
Offer a terse response. 1. What is the ratio of the Imports(as % of merchandise exports) of Tuvalu in 2004 to that in 2005?
Offer a terse response. 0.97. What is the ratio of the Imports(as % of merchandise exports) in Burundi in 2004 to that in 2006?
Your response must be concise. 0.41. What is the ratio of the Imports(as % of merchandise exports) of Cote d'Ivoire in 2004 to that in 2006?
Make the answer very short. 0.99. What is the ratio of the Imports(as % of merchandise exports) of Ireland in 2004 to that in 2006?
Offer a very short reply. 0.95. What is the ratio of the Imports(as % of merchandise exports) of Tuvalu in 2004 to that in 2006?
Give a very brief answer. 1.18. What is the ratio of the Imports(as % of merchandise exports) in Burundi in 2005 to that in 2006?
Keep it short and to the point. 0.29. What is the ratio of the Imports(as % of merchandise exports) in Cote d'Ivoire in 2005 to that in 2006?
Your answer should be very brief. 0.85. What is the ratio of the Imports(as % of merchandise exports) of Ireland in 2005 to that in 2006?
Your answer should be compact. 0.95. What is the ratio of the Imports(as % of merchandise exports) in Tuvalu in 2005 to that in 2006?
Offer a very short reply. 1.22. What is the difference between the highest and the second highest Imports(as % of merchandise exports) in Burundi?
Keep it short and to the point. 9.07. What is the difference between the highest and the second highest Imports(as % of merchandise exports) of Cote d'Ivoire?
Offer a terse response. 1.5. What is the difference between the highest and the second highest Imports(as % of merchandise exports) in Ireland?
Your answer should be very brief. 0.4. What is the difference between the highest and the second highest Imports(as % of merchandise exports) of Tuvalu?
Offer a very short reply. 0.89. What is the difference between the highest and the lowest Imports(as % of merchandise exports) in Burundi?
Make the answer very short. 15.68. What is the difference between the highest and the lowest Imports(as % of merchandise exports) of Cote d'Ivoire?
Provide a succinct answer. 7.96. What is the difference between the highest and the lowest Imports(as % of merchandise exports) in Ireland?
Provide a short and direct response. 1.53. What is the difference between the highest and the lowest Imports(as % of merchandise exports) of Tuvalu?
Make the answer very short. 7.52. 